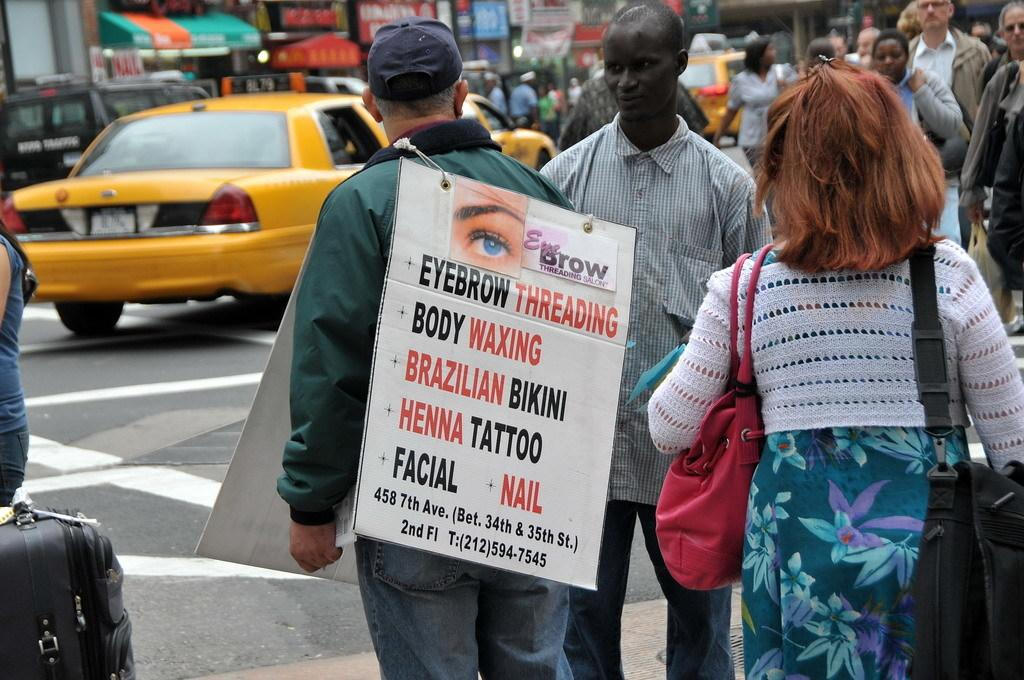Provide a one-sentence caption for the provided image. A crowd of people are walking down a busy street and a man is wearing a sign that says Eyebrow Threading. 